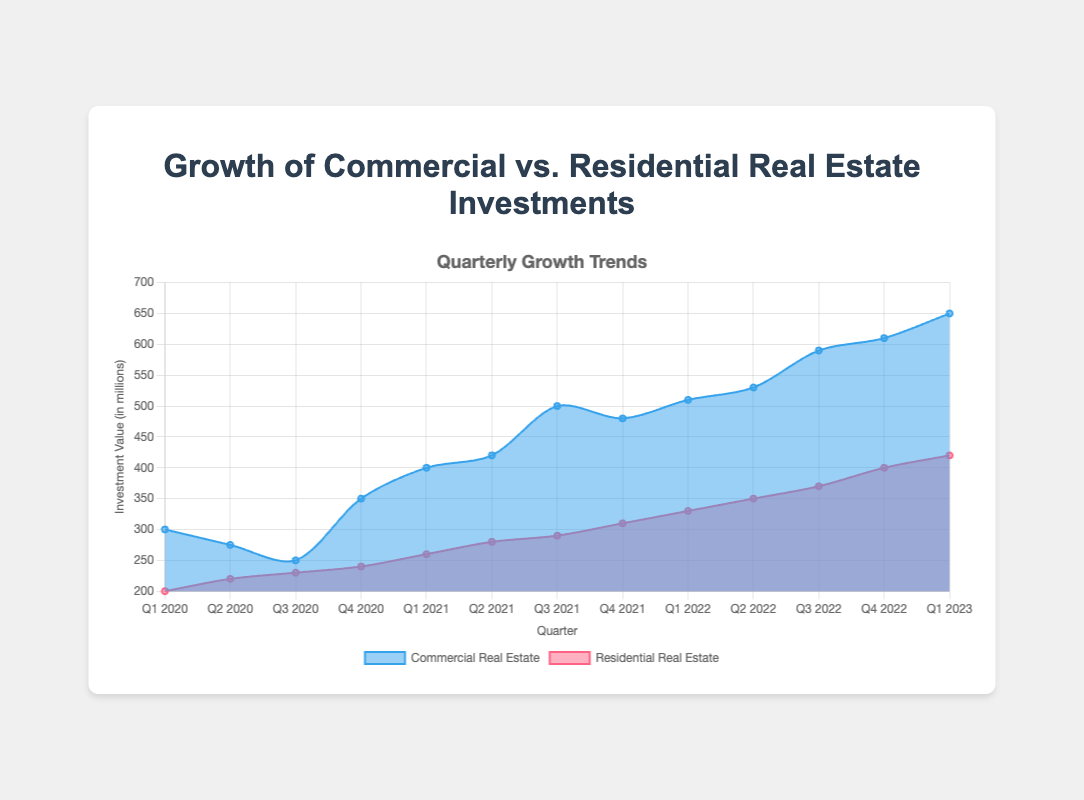What's the title of the chart? The title of the chart is usually prominently displayed at the top of the figure. In this case, it reads "Growth of Commercial vs. Residential Real Estate Investments".
Answer: Growth of Commercial vs. Residential Real Estate Investments What are the colors associated with Commercial and Residential Real Estate? The visual representation shows different background colors for each dataset. Commercial Real Estate is shaded in blue (light blue background), while Residential Real Estate is shaded in red (light red background).
Answer: Blue for Commercial, Red for Residential During which quarter did Commercial Real Estate investments first exceed 500 million? By observing the y-axis and the data points for Commercial Real Estate, we can see that the investment exceeds 500 million in Q3 2021.
Answer: Q3 2021 What is the general trend observed for Residential Real Estate investments from Q1 2020 to Q1 2023? By looking at the line graph for Residential Real Estate, we observe a consistent upward trend from about 200 million in Q1 2020 to 420 million in Q1 2023. This indicates steady growth over the quarters.
Answer: Steady upward trend What is the difference between Commercial and Residential Real Estate investments in Q4 2022? The value for Commercial Real Estate in Q4 2022 is 610 million, and for Residential Real Estate, it is 400 million. The difference is calculated as 610 - 400.
Answer: 210 million By how much did Commercial Real Estate investments grow between Q2 2020 and Q3 2020? Commercial Real Estate investments were 275 million in Q2 2020 and 250 million in Q3 2020. The difference is 250 - 275, showing a decrease.
Answer: -25 million Which dataset displayed a higher growth rate from Q1 2020 to Q1 2023, Commercial or Residential Real Estate? For Commercial Real Estate, the difference between Q1 2020 and Q1 2023 is 650 - 300 = 350 million. For Residential Real Estate, the difference is 420 - 200 = 220 million. Hence, Commercial Real Estate had a higher growth rate.
Answer: Commercial Real Estate Compare the starting values of both investments in Q1 2020. Which one had a higher initial investment value? By looking at the data points in Q1 2020, Commercial Real Estate starts at 300 million, and Residential Real Estate starts at 200 million. Therefore, Commercial Real Estate had a higher initial value.
Answer: Commercial Real Estate What was the average value of Residential Real Estate investments in 2022? The values for Residential Real Estate in 2022 are 330, 350, 370, and 400. The sum is 330 + 350 + 370 + 400 = 1450. The average is 1450 / 4 = 362.5.
Answer: 362.5 million 